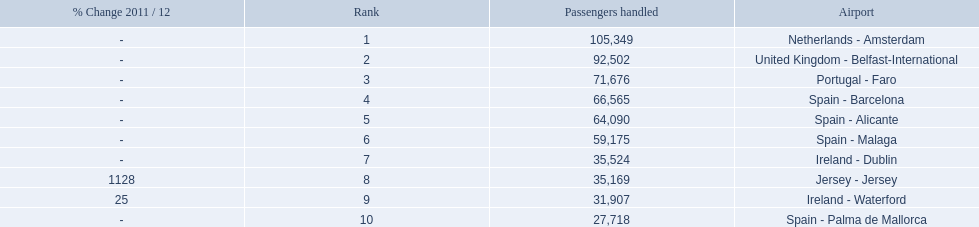Name all the london southend airports that did not list a change in 2001/12. Netherlands - Amsterdam, United Kingdom - Belfast-International, Portugal - Faro, Spain - Barcelona, Spain - Alicante, Spain - Malaga, Ireland - Dublin, Spain - Palma de Mallorca. What unchanged percentage airports from 2011/12 handled less then 50,000 passengers? Ireland - Dublin, Spain - Palma de Mallorca. What unchanged percentage airport from 2011/12 handled less then 50,000 passengers is the closest to the equator? Spain - Palma de Mallorca. 